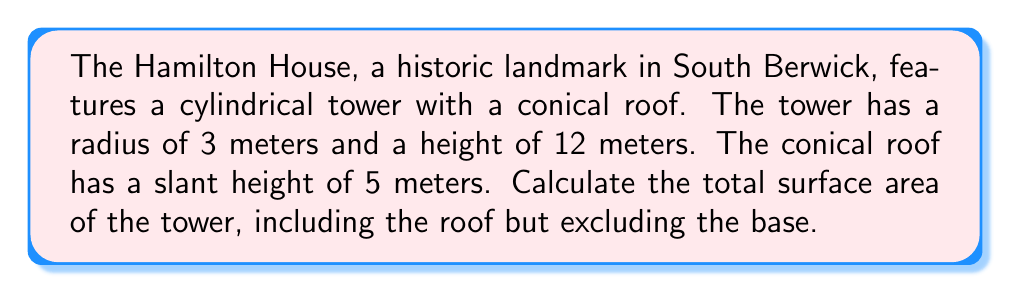Could you help me with this problem? Let's break this problem down into steps:

1. Calculate the lateral surface area of the cylindrical tower:
   $$A_{\text{cylinder}} = 2\pi rh$$
   where $r$ is the radius and $h$ is the height of the cylinder.
   $$A_{\text{cylinder}} = 2\pi \cdot 3 \cdot 12 = 72\pi \text{ m}^2$$

2. Calculate the lateral surface area of the conical roof:
   $$A_{\text{cone}} = \pi rs$$
   where $r$ is the radius of the base and $s$ is the slant height.
   $$A_{\text{cone}} = \pi \cdot 3 \cdot 5 = 15\pi \text{ m}^2$$

3. Sum up the areas:
   $$A_{\text{total}} = A_{\text{cylinder}} + A_{\text{cone}}$$
   $$A_{\text{total}} = 72\pi \text{ m}^2 + 15\pi \text{ m}^2 = 87\pi \text{ m}^2$$

[asy]
import geometry;

size(200);
draw(circle((0,0),3));
draw((0,0)--(3,0));
draw((0,0)--(0,12));
draw((3,0)--(3,12));
draw((0,12)--(3,12));
draw((0,12)--(1.8,16));
draw((3,12)--(1.8,16));
label("3m",(1.5,0),S);
label("12m",(3.5,6),E);
label("5m",(2.4,14),NE);
[/asy]
Answer: $87\pi \text{ m}^2$ 